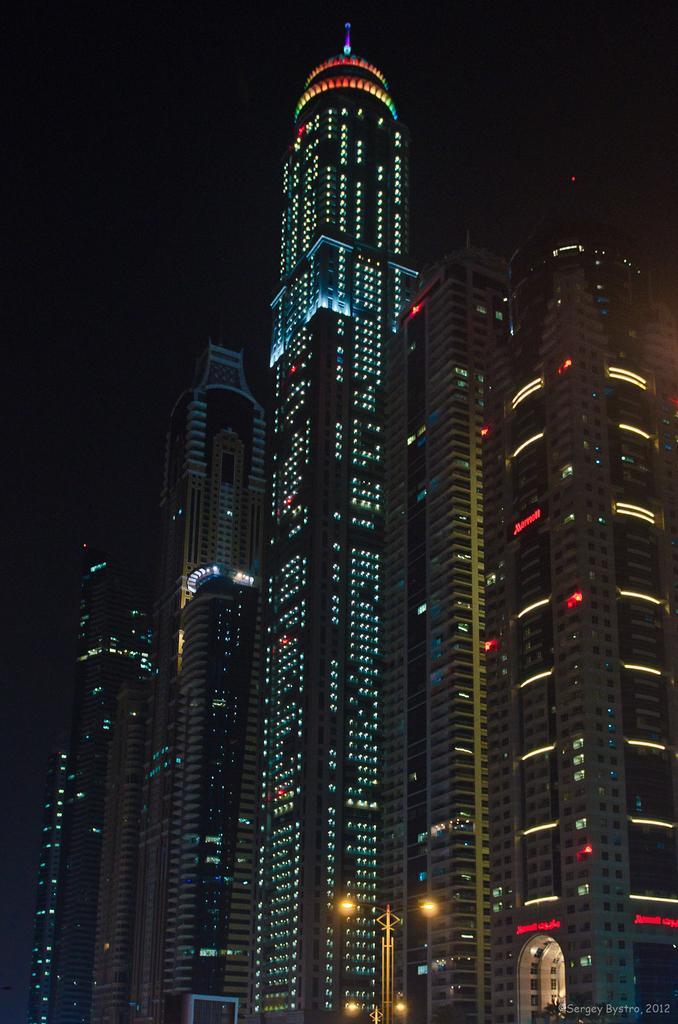Can you describe this image briefly? In this picture there is a huge building with full of lights and the background of the picture and at the top it's very dark. 